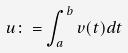Convert formula to latex. <formula><loc_0><loc_0><loc_500><loc_500>u \colon = \int _ { a } ^ { b } v ( t ) d t</formula> 